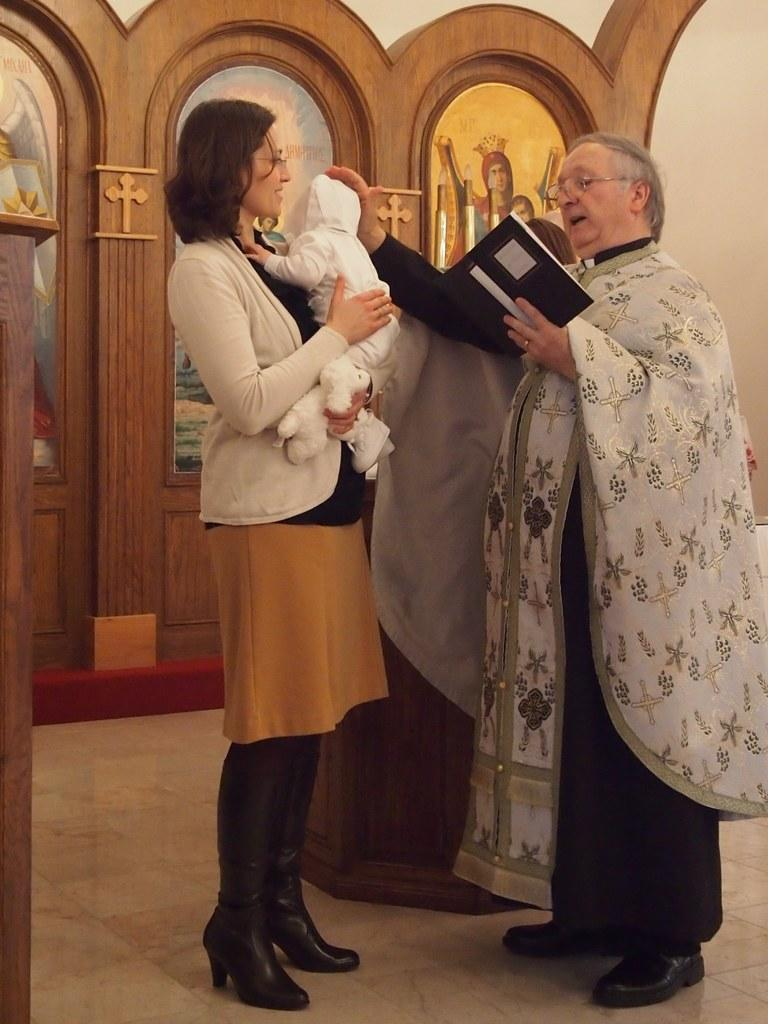What is the woman in the image doing? The woman is standing in the image and holding a kid. Can you describe the person on the right side of the image? The person on the right side of the image is standing and holding a book. What can be seen on the floor in the image? The floor is visible in the image. What type of structure is the woman using to support to hold the kid in the image? There is no structure visible in the image that the woman is using to hold the kid; she is simply holding the kid in her arms. What color is the string tied around the sock on the person's foot in the image? There is no sock or string present on the person's foot in the image. 